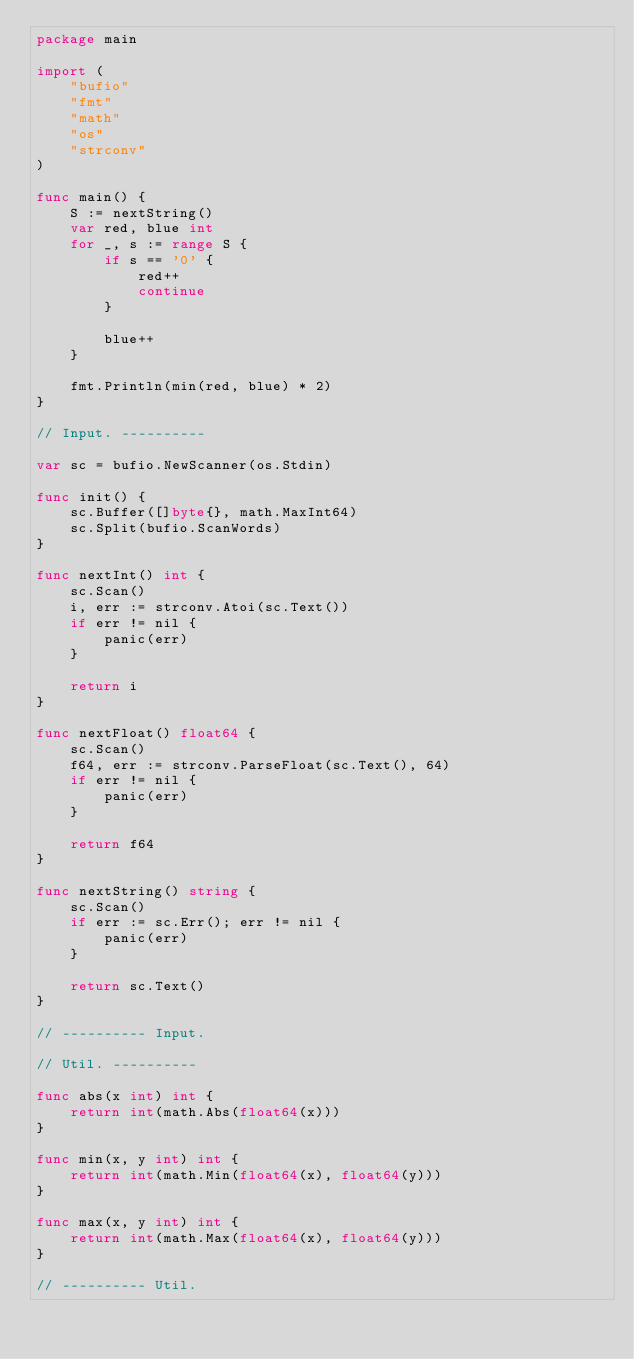<code> <loc_0><loc_0><loc_500><loc_500><_Go_>package main

import (
	"bufio"
	"fmt"
	"math"
	"os"
	"strconv"
)

func main() {
	S := nextString()
	var red, blue int
	for _, s := range S {
		if s == '0' {
			red++
			continue
		}

		blue++
	}

	fmt.Println(min(red, blue) * 2)
}

// Input. ----------

var sc = bufio.NewScanner(os.Stdin)

func init() {
	sc.Buffer([]byte{}, math.MaxInt64)
	sc.Split(bufio.ScanWords)
}

func nextInt() int {
	sc.Scan()
	i, err := strconv.Atoi(sc.Text())
	if err != nil {
		panic(err)
	}

	return i
}

func nextFloat() float64 {
	sc.Scan()
	f64, err := strconv.ParseFloat(sc.Text(), 64)
	if err != nil {
		panic(err)
	}

	return f64
}

func nextString() string {
	sc.Scan()
	if err := sc.Err(); err != nil {
		panic(err)
	}

	return sc.Text()
}

// ---------- Input.

// Util. ----------

func abs(x int) int {
	return int(math.Abs(float64(x)))
}

func min(x, y int) int {
	return int(math.Min(float64(x), float64(y)))
}

func max(x, y int) int {
	return int(math.Max(float64(x), float64(y)))
}

// ---------- Util.
</code> 